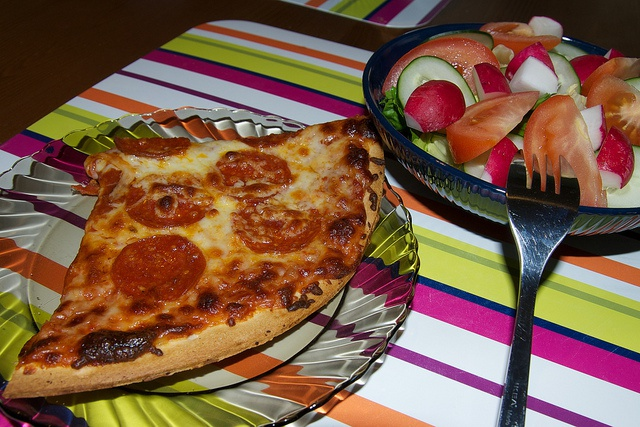Describe the objects in this image and their specific colors. I can see dining table in black, lightgray, darkgray, and olive tones, pizza in black, brown, maroon, and tan tones, bowl in black and brown tones, and fork in black, navy, blue, and gray tones in this image. 